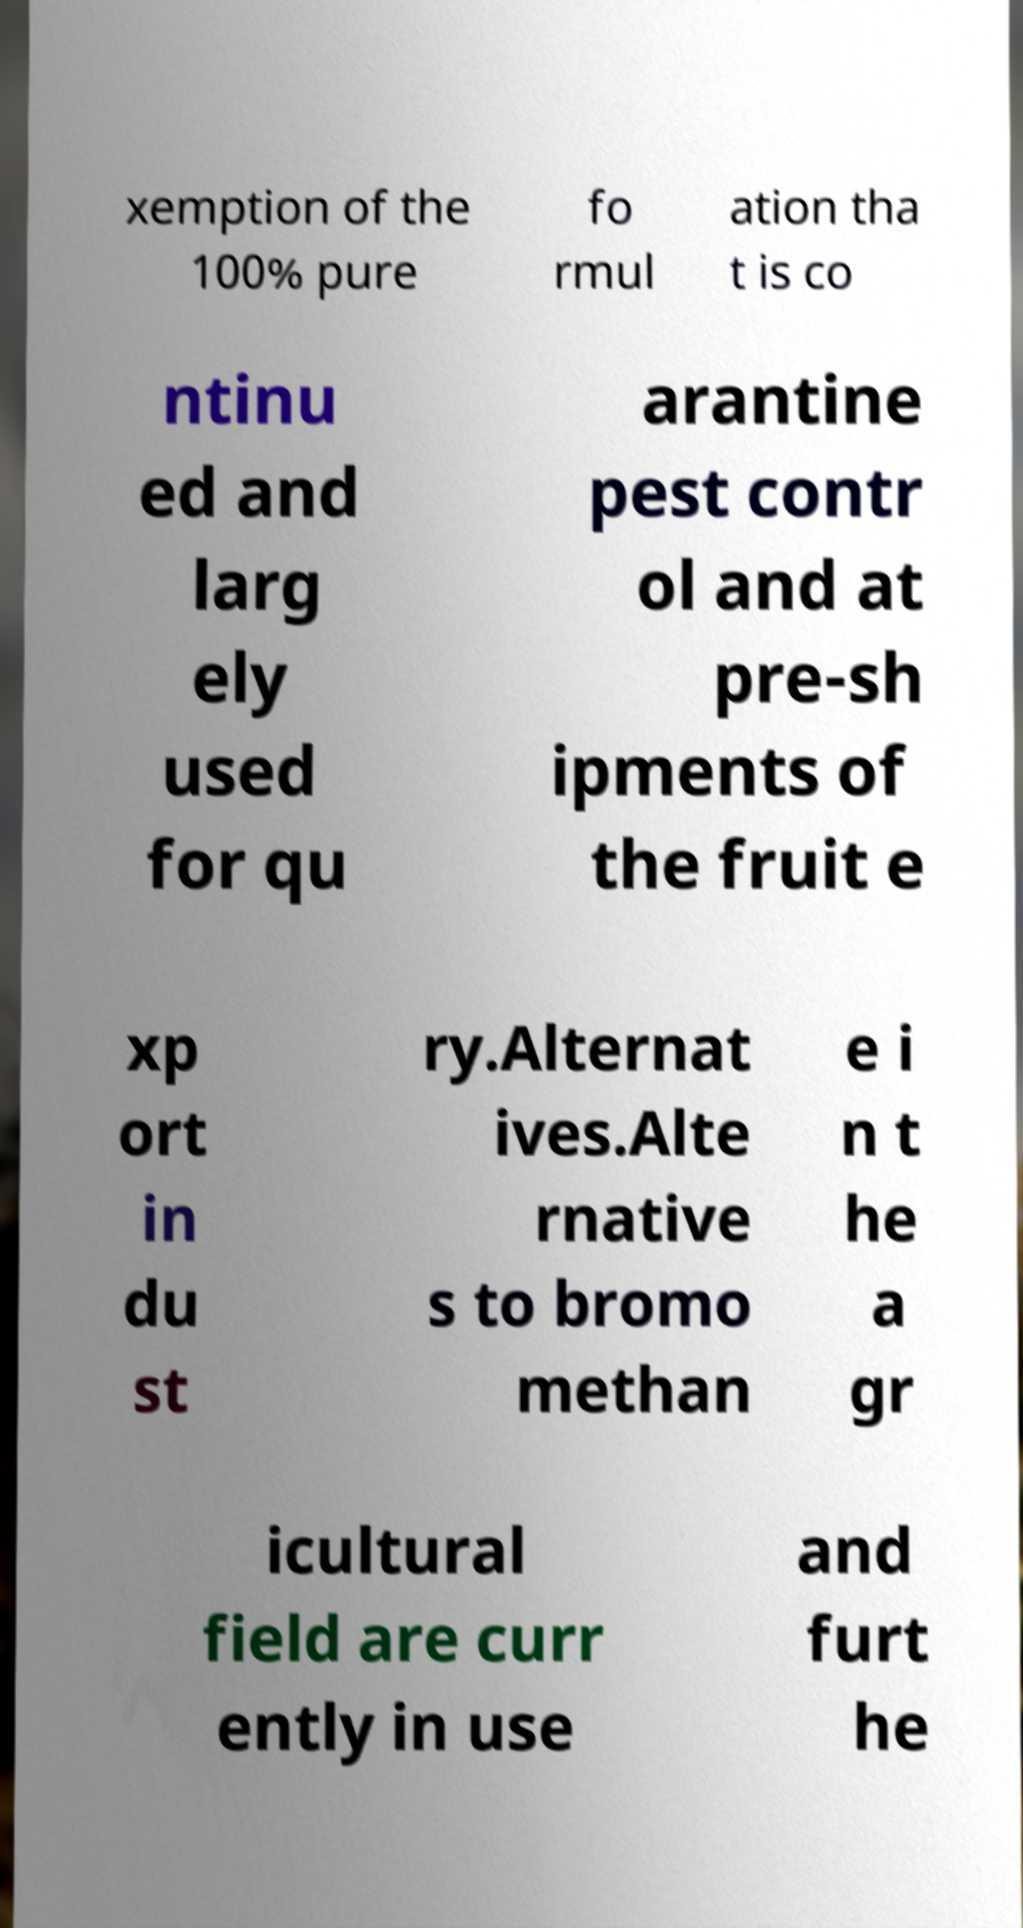Could you assist in decoding the text presented in this image and type it out clearly? xemption of the 100% pure fo rmul ation tha t is co ntinu ed and larg ely used for qu arantine pest contr ol and at pre-sh ipments of the fruit e xp ort in du st ry.Alternat ives.Alte rnative s to bromo methan e i n t he a gr icultural field are curr ently in use and furt he 